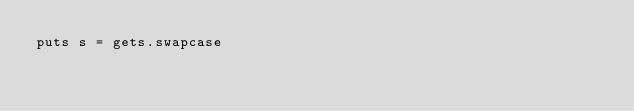Convert code to text. <code><loc_0><loc_0><loc_500><loc_500><_Ruby_>puts s = gets.swapcase</code> 